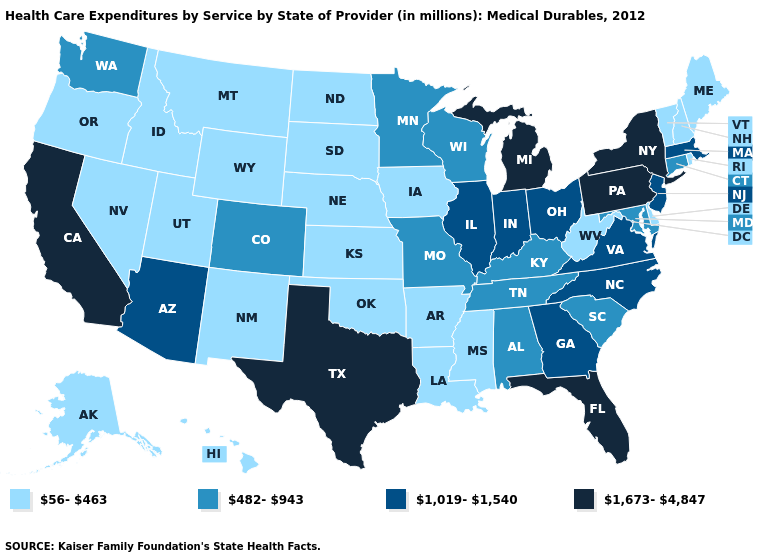What is the value of South Carolina?
Keep it brief. 482-943. What is the value of Ohio?
Be succinct. 1,019-1,540. What is the value of Michigan?
Write a very short answer. 1,673-4,847. Which states have the lowest value in the USA?
Concise answer only. Alaska, Arkansas, Delaware, Hawaii, Idaho, Iowa, Kansas, Louisiana, Maine, Mississippi, Montana, Nebraska, Nevada, New Hampshire, New Mexico, North Dakota, Oklahoma, Oregon, Rhode Island, South Dakota, Utah, Vermont, West Virginia, Wyoming. Among the states that border New Jersey , which have the highest value?
Answer briefly. New York, Pennsylvania. What is the value of Missouri?
Be succinct. 482-943. Name the states that have a value in the range 1,673-4,847?
Answer briefly. California, Florida, Michigan, New York, Pennsylvania, Texas. Does Indiana have a higher value than Michigan?
Keep it brief. No. What is the highest value in states that border Ohio?
Short answer required. 1,673-4,847. Among the states that border Wisconsin , does Michigan have the highest value?
Concise answer only. Yes. What is the lowest value in the USA?
Be succinct. 56-463. Which states hav the highest value in the Northeast?
Be succinct. New York, Pennsylvania. Among the states that border Washington , which have the lowest value?
Answer briefly. Idaho, Oregon. Does Nevada have the highest value in the USA?
Answer briefly. No. What is the lowest value in states that border Virginia?
Short answer required. 56-463. 